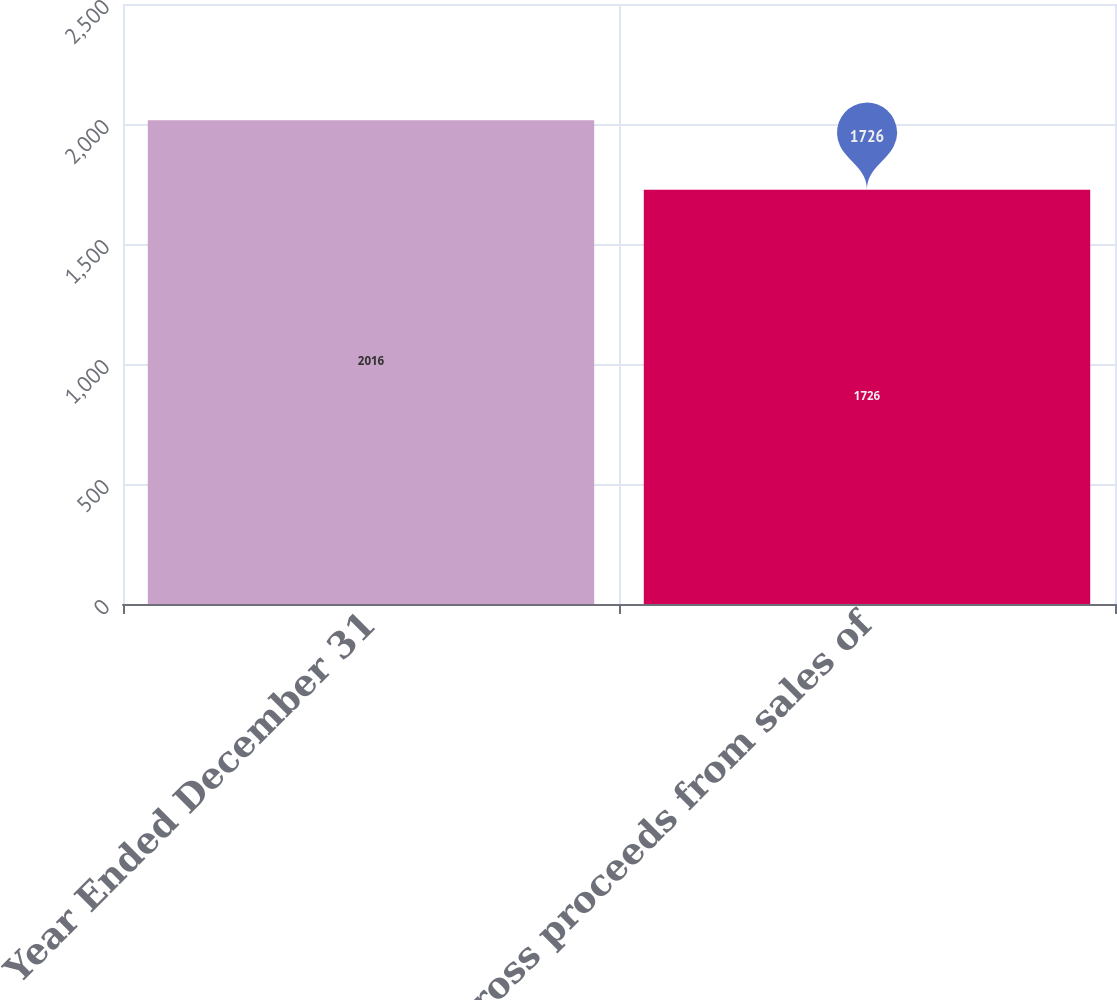Convert chart to OTSL. <chart><loc_0><loc_0><loc_500><loc_500><bar_chart><fcel>Year Ended December 31<fcel>Gross proceeds from sales of<nl><fcel>2016<fcel>1726<nl></chart> 